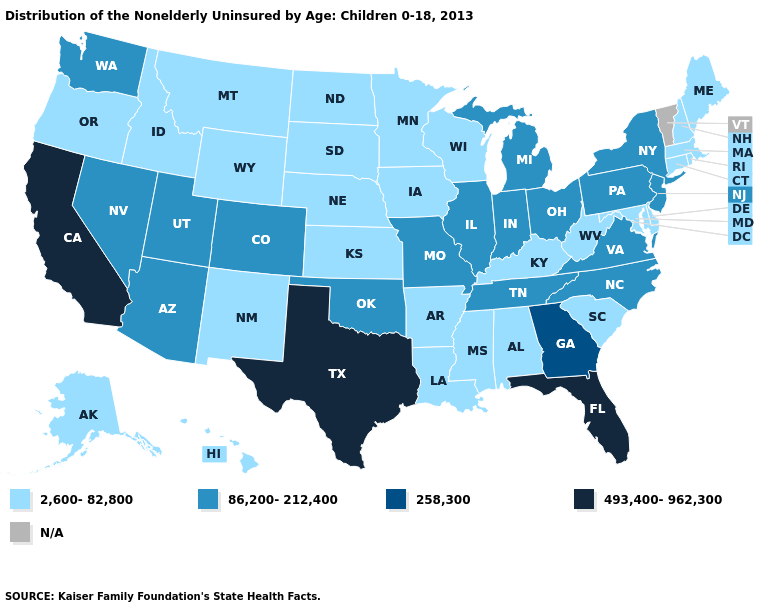What is the lowest value in states that border Mississippi?
Keep it brief. 2,600-82,800. Does Georgia have the lowest value in the USA?
Write a very short answer. No. What is the highest value in the MidWest ?
Be succinct. 86,200-212,400. Which states hav the highest value in the MidWest?
Give a very brief answer. Illinois, Indiana, Michigan, Missouri, Ohio. Which states have the highest value in the USA?
Answer briefly. California, Florida, Texas. Name the states that have a value in the range 493,400-962,300?
Concise answer only. California, Florida, Texas. What is the value of Missouri?
Keep it brief. 86,200-212,400. What is the value of Colorado?
Keep it brief. 86,200-212,400. Which states have the highest value in the USA?
Answer briefly. California, Florida, Texas. What is the lowest value in the South?
Be succinct. 2,600-82,800. Name the states that have a value in the range 258,300?
Answer briefly. Georgia. How many symbols are there in the legend?
Concise answer only. 5. 